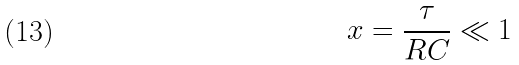<formula> <loc_0><loc_0><loc_500><loc_500>x = \frac { \tau } { R C } \ll 1</formula> 